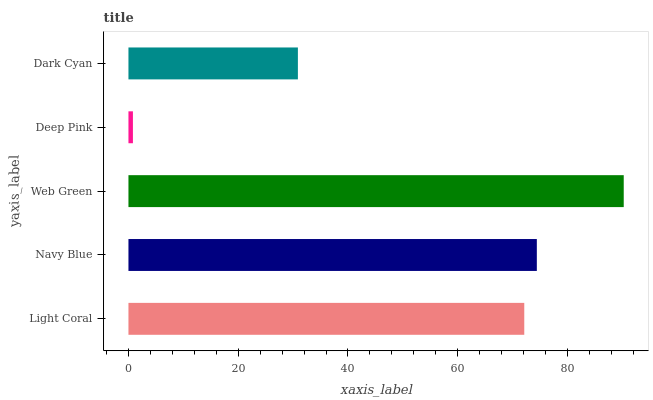Is Deep Pink the minimum?
Answer yes or no. Yes. Is Web Green the maximum?
Answer yes or no. Yes. Is Navy Blue the minimum?
Answer yes or no. No. Is Navy Blue the maximum?
Answer yes or no. No. Is Navy Blue greater than Light Coral?
Answer yes or no. Yes. Is Light Coral less than Navy Blue?
Answer yes or no. Yes. Is Light Coral greater than Navy Blue?
Answer yes or no. No. Is Navy Blue less than Light Coral?
Answer yes or no. No. Is Light Coral the high median?
Answer yes or no. Yes. Is Light Coral the low median?
Answer yes or no. Yes. Is Deep Pink the high median?
Answer yes or no. No. Is Deep Pink the low median?
Answer yes or no. No. 